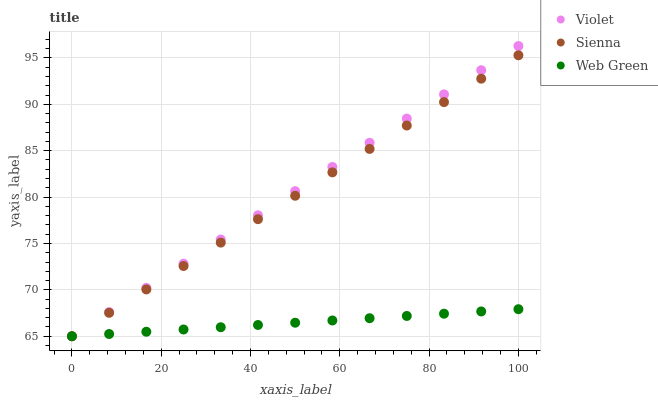Does Web Green have the minimum area under the curve?
Answer yes or no. Yes. Does Violet have the maximum area under the curve?
Answer yes or no. Yes. Does Violet have the minimum area under the curve?
Answer yes or no. No. Does Web Green have the maximum area under the curve?
Answer yes or no. No. Is Web Green the smoothest?
Answer yes or no. Yes. Is Sienna the roughest?
Answer yes or no. Yes. Is Violet the smoothest?
Answer yes or no. No. Is Violet the roughest?
Answer yes or no. No. Does Sienna have the lowest value?
Answer yes or no. Yes. Does Violet have the highest value?
Answer yes or no. Yes. Does Web Green have the highest value?
Answer yes or no. No. Does Web Green intersect Sienna?
Answer yes or no. Yes. Is Web Green less than Sienna?
Answer yes or no. No. Is Web Green greater than Sienna?
Answer yes or no. No. 